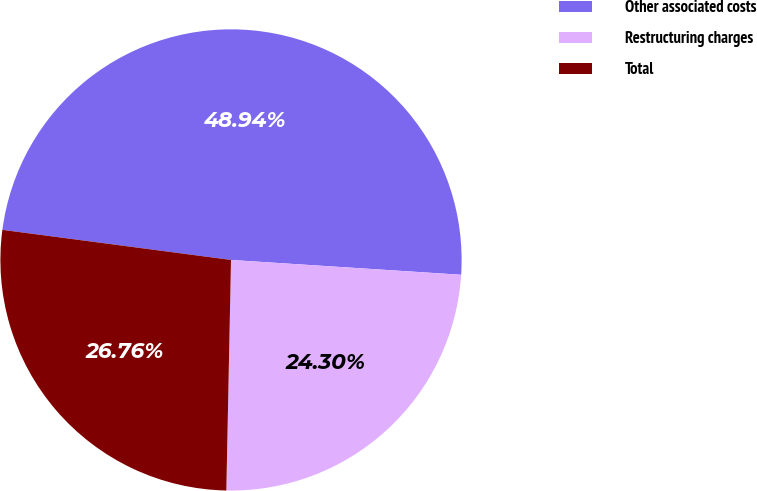<chart> <loc_0><loc_0><loc_500><loc_500><pie_chart><fcel>Other associated costs<fcel>Restructuring charges<fcel>Total<nl><fcel>48.94%<fcel>24.3%<fcel>26.76%<nl></chart> 